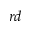<formula> <loc_0><loc_0><loc_500><loc_500>^ { r d }</formula> 